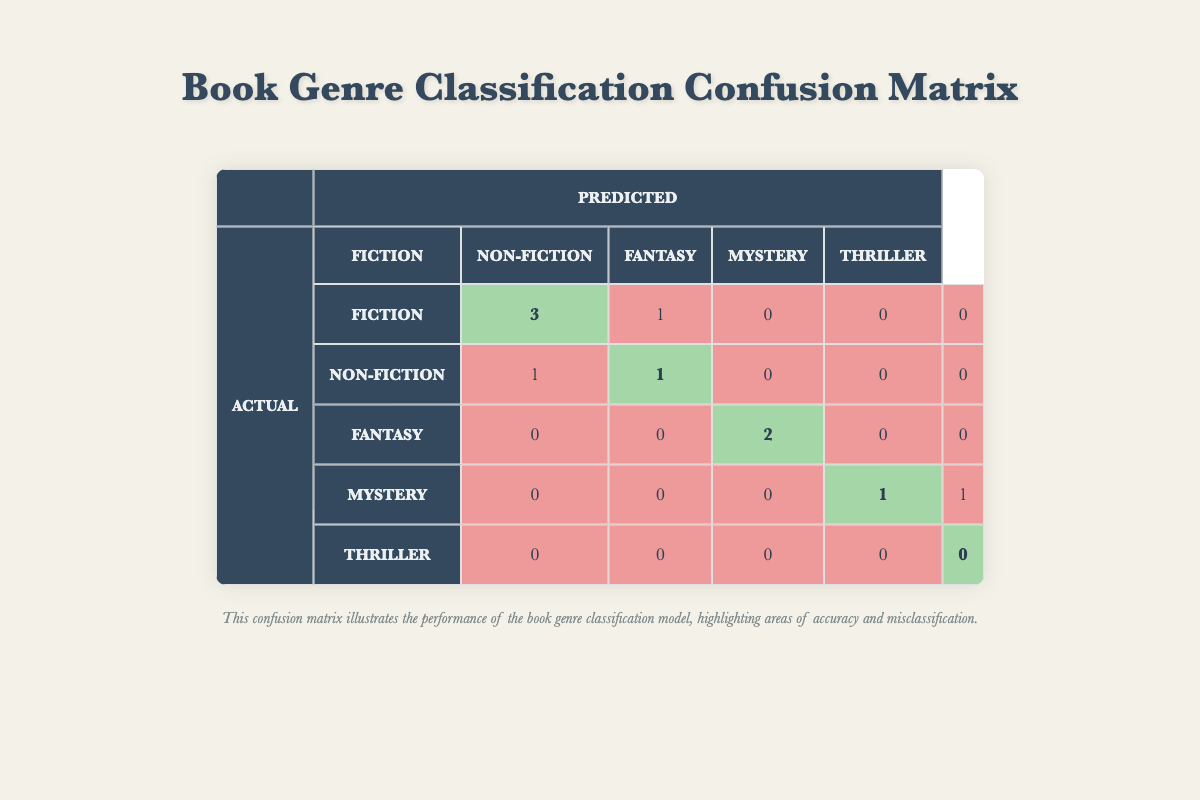What is the True Positive rate for Fiction? The True Positive rate for Fiction is calculated by taking the number of True Positives, which is 4, and dividing it by the total actual Fiction instances, which is the sum of True Positives and False Negatives (4 + 1 = 5). Therefore, the True Positive rate is 4/5 or 0.8.
Answer: 0.8 How many True Negatives are there for the Fantasy genre? The number of True Negatives for the Fantasy genre is directly provided in the table. It shows there are 6 True Negatives.
Answer: 6 What is the total number of False Positives across all genres? To find the total number of False Positives, we add up the False Positives for all genres: Fiction (1) + Non-Fiction (2) + Fantasy (0) + Mystery (1) + Thriller (1) = 5.
Answer: 5 Is it true that there are no True Positives for the Thriller genre? The table states that the True Positives for the Thriller genre are 0, indicating there are indeed no True Positives.
Answer: Yes Which genre has the highest True Negative count and what is that count? By examining the True Negatives in the table for each genre: Fiction (2), Non-Fiction (4), Fantasy (6), Mystery (7), Thriller (9), it is clear that the genre with the highest True Negative count is Thriller with 9 True Negatives.
Answer: Thriller, 9 What is the difference in True Positives between the Fiction and Non-Fiction genres? For Fiction, the True Positives are 4 and for Non-Fiction, they are 2. To find the difference, we subtract: 4 - 2 = 2.
Answer: 2 How many total predictions were made for the Mystery genre? To calculate the total predictions for the Mystery genre, we add the True Positives, False Positives, and False Negatives together: True Positives (1) + False Positives (1) + False Negatives (1) = 3.
Answer: 3 What percentage of the total predictions were correct? To find the percentage of correct predictions, we calculate the total correct predictions as the sum of True Positives (4 + 2 + 2 + 1 + 0) = 9, and the total predictions as the sum of all values in the matrix. Total predictions are 10. The correct prediction percentage is (9/10) * 100 = 90%.
Answer: 90% What is the average number of True Positives across all genres? To find the average number of True Positives, we sum the True Positives for each genre: (4 + 2 + 2 + 1 + 0) = 9, and divide by the number of genres, which is 5. Thus, the average is 9/5 = 1.8.
Answer: 1.8 